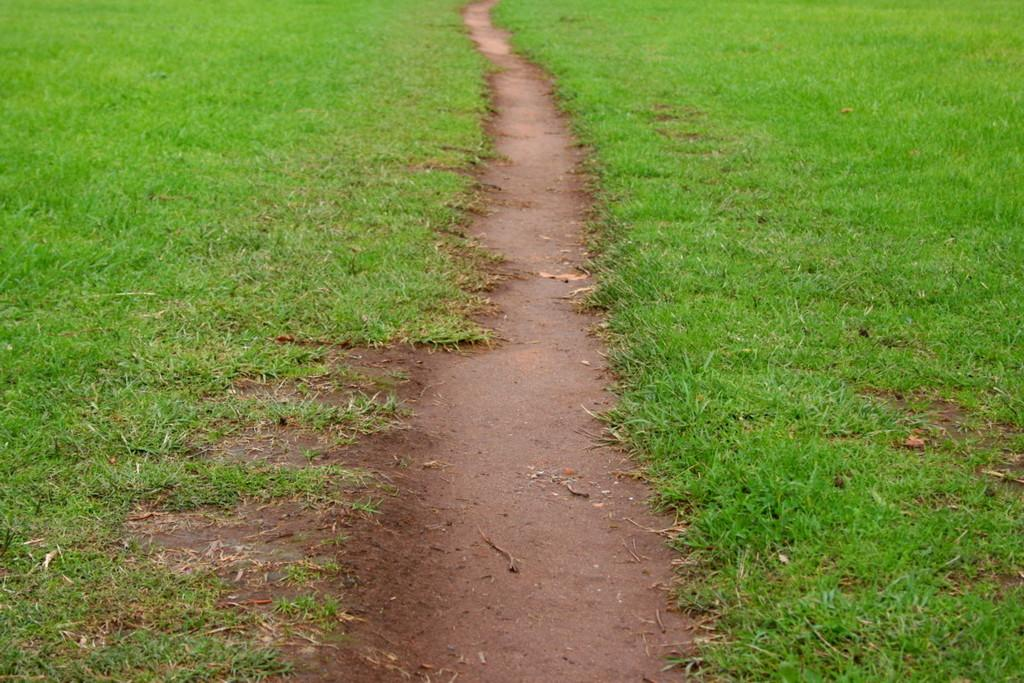What type of vegetation is present in the image? There is grass in the image. What kind of surface can be seen in the image? There is a pathway in the image. What type of bun can be seen on the coast in the image? There is no bun or coast present in the image; it only features grass and a pathway. 